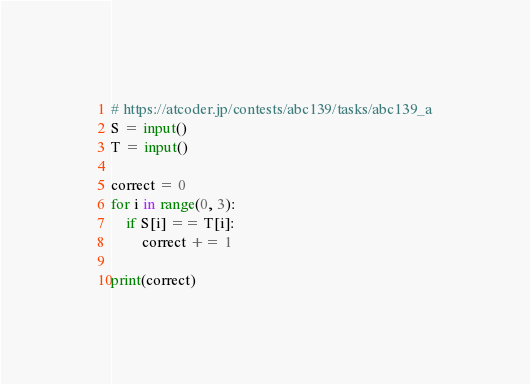<code> <loc_0><loc_0><loc_500><loc_500><_Python_># https://atcoder.jp/contests/abc139/tasks/abc139_a
S = input()
T = input()

correct = 0
for i in range(0, 3):
    if S[i] == T[i]:
        correct += 1
        
print(correct)</code> 